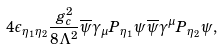Convert formula to latex. <formula><loc_0><loc_0><loc_500><loc_500>4 \epsilon _ { \eta _ { 1 } \eta _ { 2 } } \frac { g ^ { 2 } _ { c } } { 8 \Lambda ^ { 2 } } \overline { \psi } \gamma _ { \mu } P _ { \eta _ { 1 } } \psi \, \overline { \psi } \gamma ^ { \mu } P _ { \eta _ { 2 } } \psi ,</formula> 